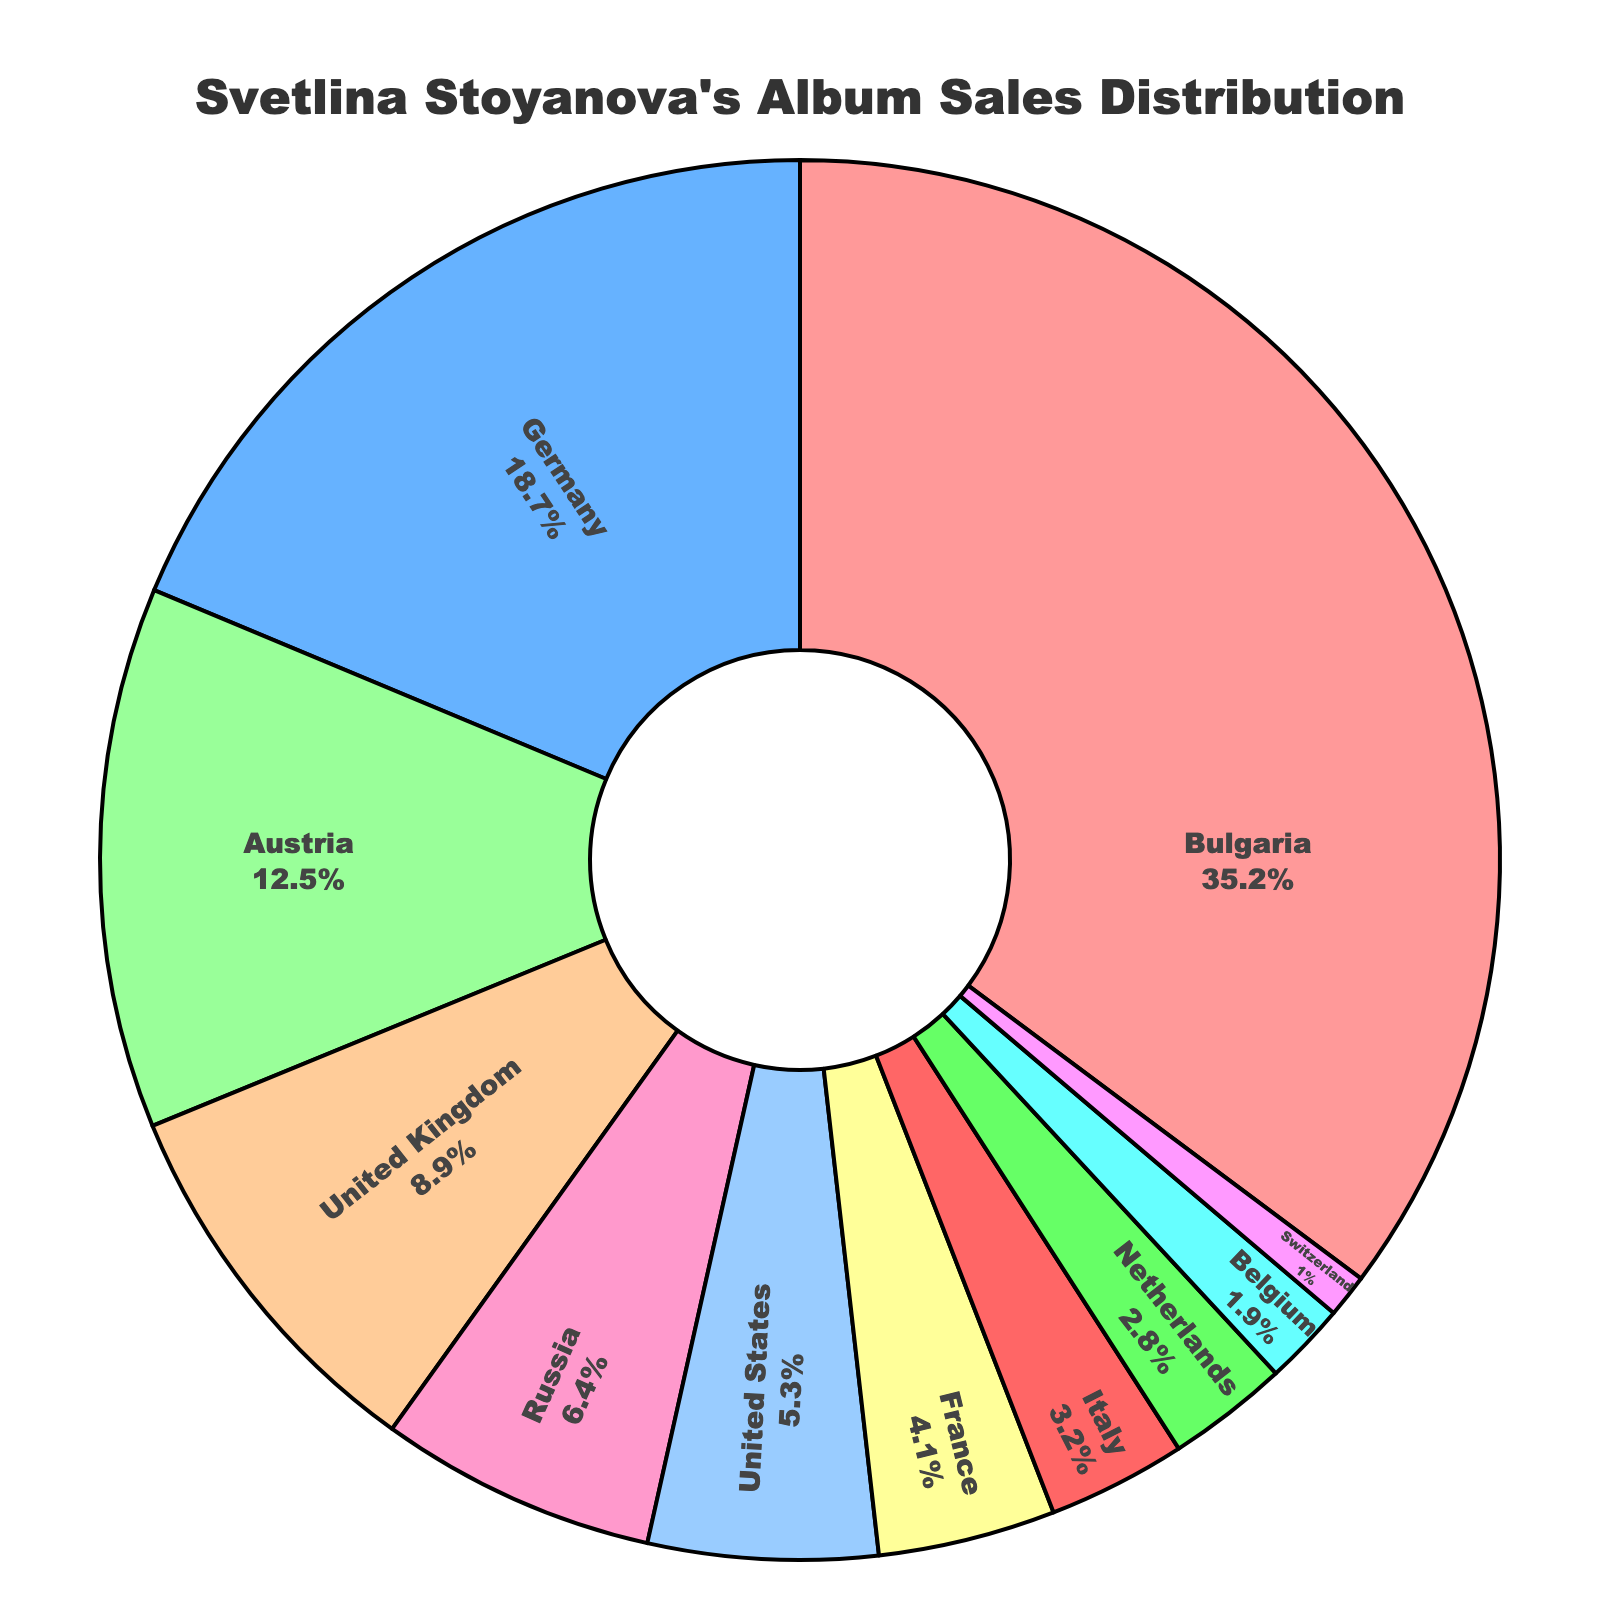Which country has the highest album sales percentage? The pie chart shows each country's album sales percentage by the size of its segment. The largest segment corresponds to Bulgaria.
Answer: Bulgaria Which countries have album sales percentages greater than 10%? Visually inspect the pie chart and identify segments with percentages more than 10%. The countries are Bulgaria, Germany, and Austria.
Answer: Bulgaria, Germany, Austria What is the combined album sales percentage for the United Kingdom and France? Add the percentages for the United Kingdom (8.9%) and France (4.1%). 8.9 + 4.1 = 13.0
Answer: 13.0 How much more is Bulgaria's album sales percentage compared to the United States? Subtract the United States percentage (5.3%) from Bulgaria's percentage (35.2%). 35.2 - 5.3 = 29.9
Answer: 29.9 Which country has the smallest album sales percentage? The pie chart shows each country's album sales percentage by the size of its segment. The smallest segment corresponds to Switzerland.
Answer: Switzerland What is the average album sales percentage for the four countries with the highest sales? Identify the top four countries: Bulgaria (35.2%), Germany (18.7%), Austria (12.5%), and United Kingdom (8.9%). Then calculate their average: (35.2 + 18.7 + 12.5 + 8.9) / 4 = 18.825
Answer: 18.825 Which two countries together account for approximately one-quarter of the total album sales? Look for two countries whose combined percentage is around 25%. Germany (18.7%) and Austria (12.5%) sum up to 31.2%, while the United Kingdom (8.9%) and Russia (6.4%) sum up to 15.3%, which is closer. The United States (5.3%) could be combined with Austria (12.5%) for 17.8%, but this is not closer. The best combination is Bulgaria (35.2%) + United Kingdom (8.9%) for 44.1%, but it significantly overshoots 25%. Now, Germany (18.7%) + Netherlands (2.8%) gets us 21.5%. Still, the closest pair without overshooting too much might be Germany and Austria again.
Answer: Germany, Austria How does the album sales percentage for France compare to that of Belgium and Switzerland combined? Add the percentages for Belgium (1.9%) and Switzerland (1.0%). 1.9 + 1.0 = 2.9. Compare this to France's percentage (4.1%). France (4.1) > Belgium + Switzerland (2.9)
Answer: France's percentage is higher What is the difference in album sales percentage between Austria and Italy? Subtract Italy’s percentage (3.2%) from Austria's percentage (12.5%). 12.5 - 3.2 = 9.3
Answer: 9.3 